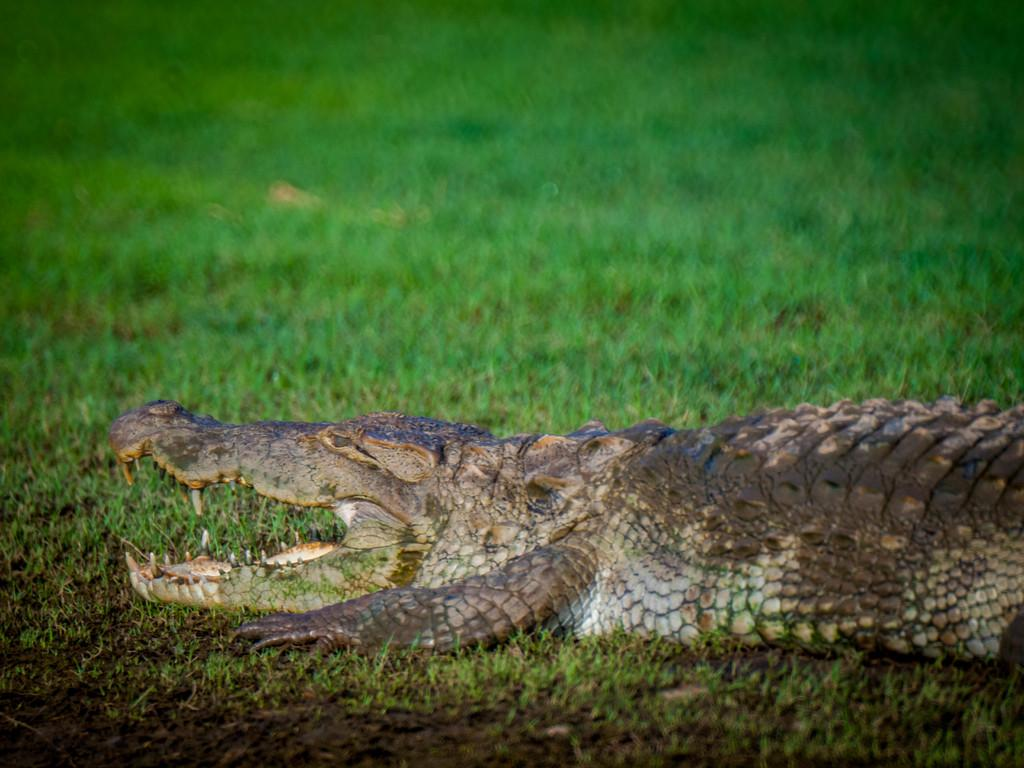What type of animal is in the image? There is a crocodile in the image. Where is the crocodile located? The crocodile is on the surface of the grass. What type of steam can be seen coming from the crocodile's mouth in the image? There is no steam coming from the crocodile's mouth in the image. What type of rifle is the crocodile holding in the image? The crocodile is not holding a rifle in the image. 